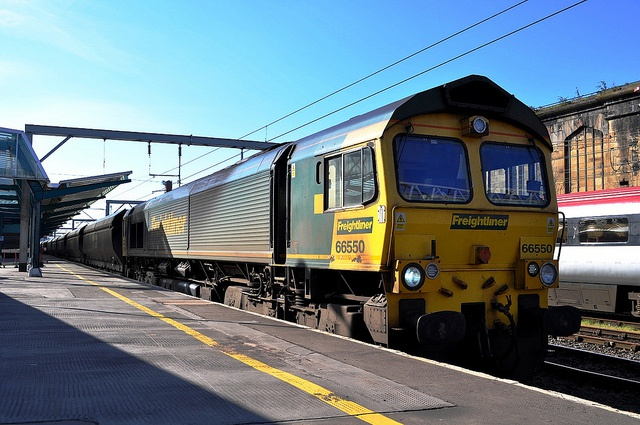Describe the objects in this image and their specific colors. I can see train in lightblue, black, olive, gray, and darkgray tones and train in lightblue, white, gray, black, and darkgray tones in this image. 